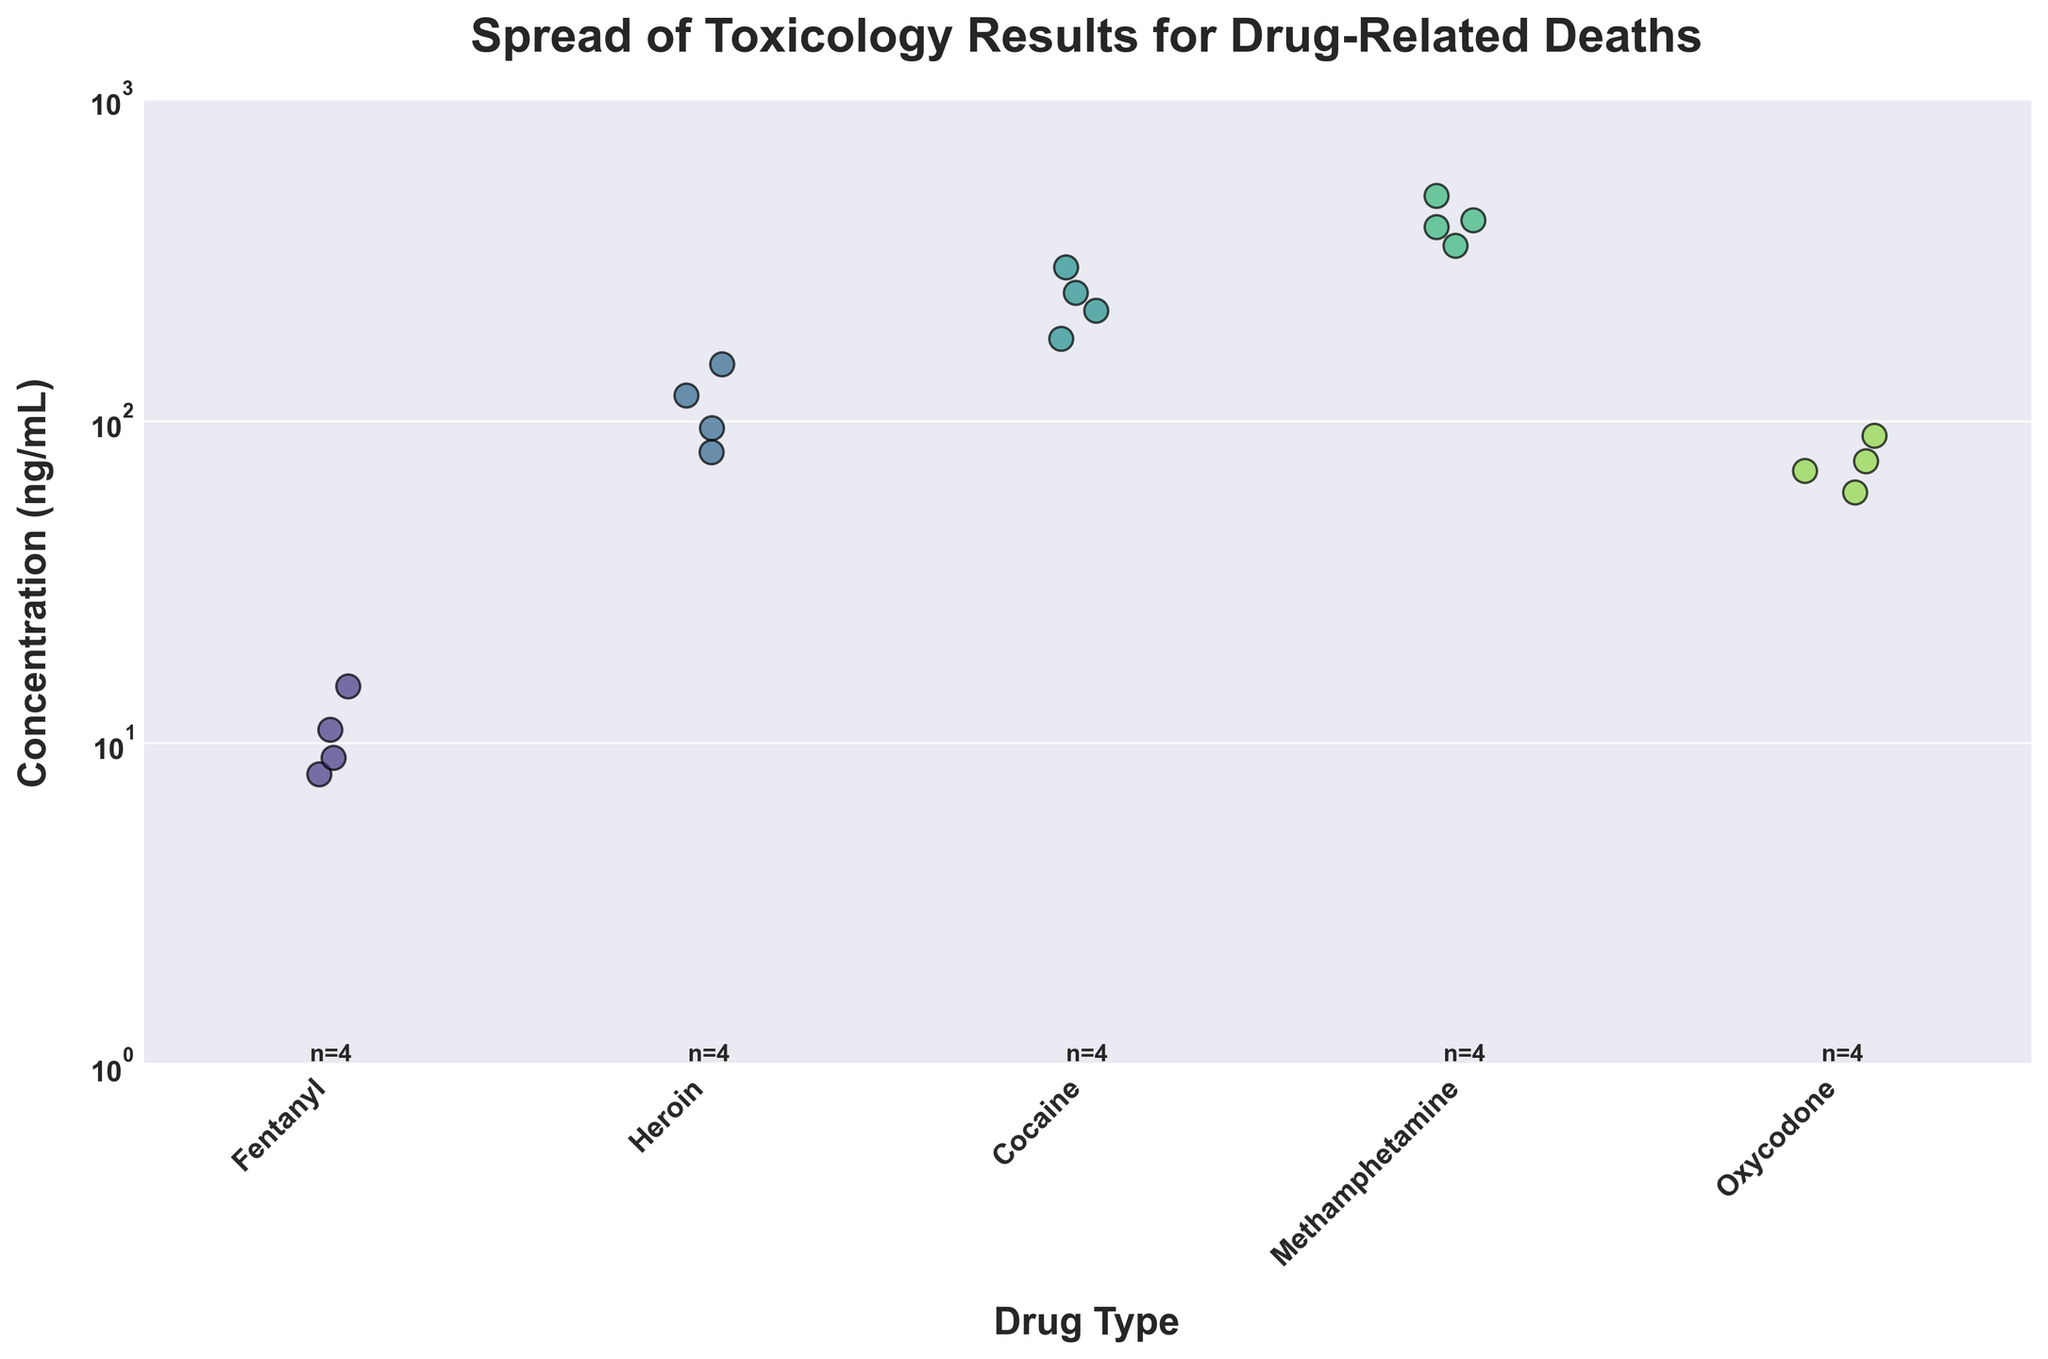What is the title of the figure? The title is usually found at the top of the figure, providing a summary of what the data represents. In this case, the title reads "Spread of Toxicology Results for Drug-Related Deaths"
Answer: Spread of Toxicology Results for Drug-Related Deaths What are the x-axis and y-axis labels of the figure? The x-axis represents the different types of drugs, and the y-axis represents the concentration of these drugs measured in ng/mL. This information is found on the horizontal and vertical axes.
Answer: Drug Type and Concentration (ng/mL) How many types of drugs are displayed in the figure? Each distinct category along the x-axis represents a different type of drug. By counting these categories, we see there are five types: Fentanyl, Heroin, Cocaine, Methamphetamine, and Oxycodone.
Answer: 5 Which drug has the highest single concentration value in the figure? By visually scanning the heights of the strip plot on the y-axis, the drug with the highest single point lies in the Methamphetamine category at 500 ng/mL.
Answer: Methamphetamine How many data points are there for each drug type? The number of data points for each drug type is indicated by text annotations below the x-axis. They are n=4 for Fentanyl, n=4 for Heroin, n=4 for Cocaine, n=4 for Methamphetamine, and n=4 for Oxycodone.
Answer: 4 for each What is the median concentration value for Oxycodone? The median value separates the data points into equal halves. For Oxycodone, ordering the concentrations (60, 70, 75, 90), the median is the average of the two middle values (70+75)/2.
Answer: 72.5 ng/mL Compare the concentration ranges of Fentanyl and Heroin. Fentanyl ranges from 8 to 15 ng/mL, while Heroin ranges from 80 to 150 ng/mL. This indicates that Heroin has a broader and higher range of concentrations compared to Fentanyl.
Answer: Heroin has a broader and higher range Among the five drugs, which one has the narrowest range of concentration values? The range of each drug can be calculated by subtracting the minimum concentration from the maximum concentration. By looking at the strip plot, Fentanyl (15-8=7) has the narrowest range.
Answer: Fentanyl Why is a logarithmic scale used for the y-axis in this figure? A logarithmic scale is used to better visualize data that spans a wide range of values. In this case, the concentrations of different drugs vary significantly, and the logarithmic scale helps to display all values more uniformly.
Answer: To better visualize the wide range of values Which drug shows the most consistent concentration results (i.e., lowest variability)? Consistency is indicated by the closeness of data points to each other. Fentanyl has the least spread of values (between 8 to 15 ng/mL), suggesting the most consistent concentration results.
Answer: Fentanyl 